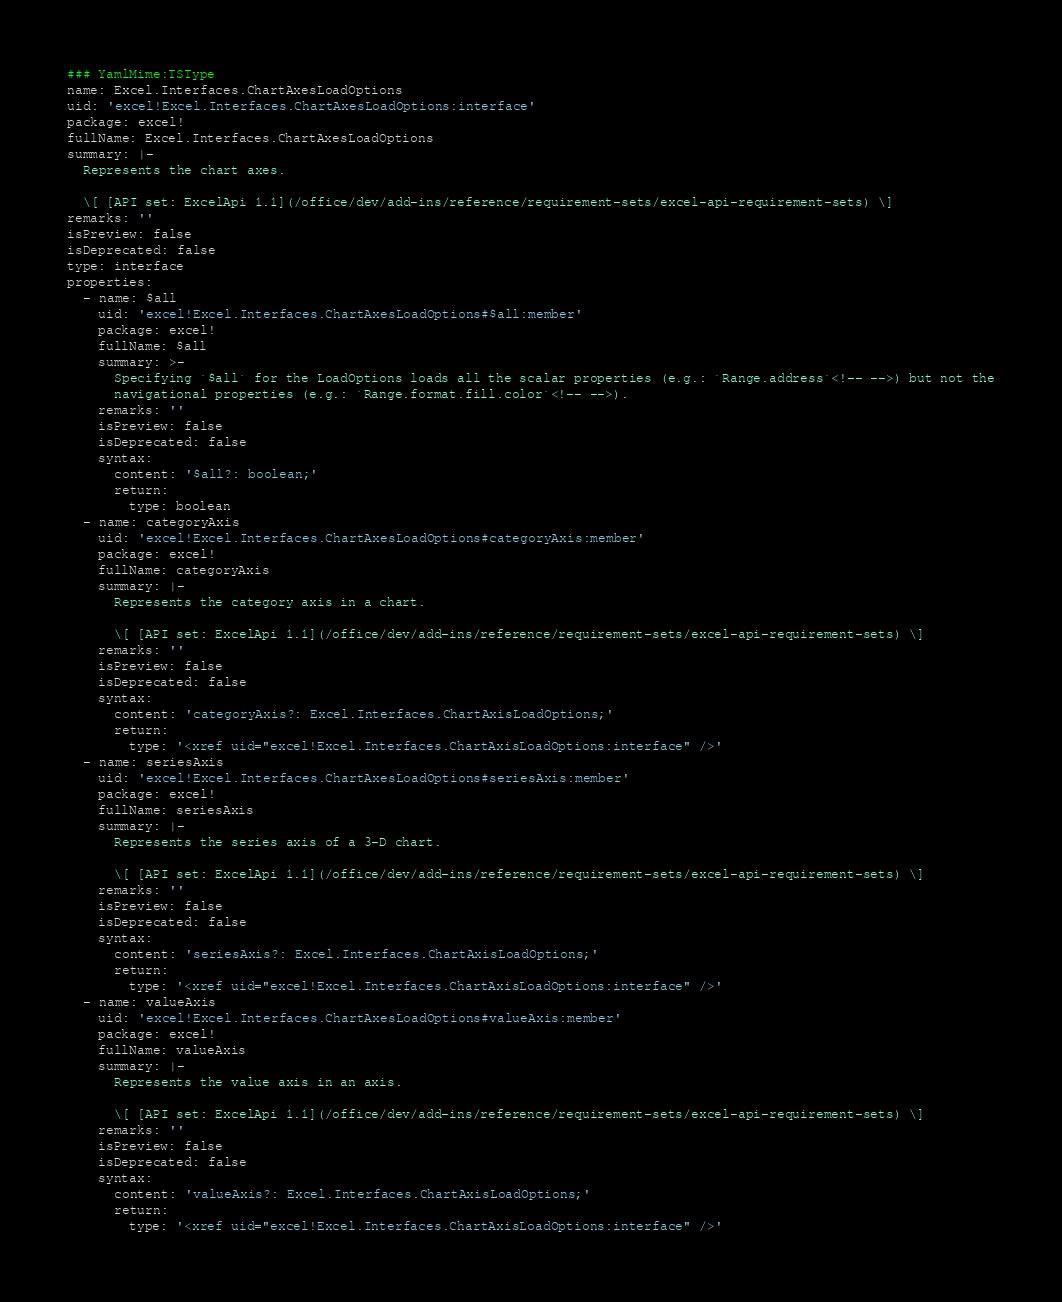<code> <loc_0><loc_0><loc_500><loc_500><_YAML_>### YamlMime:TSType
name: Excel.Interfaces.ChartAxesLoadOptions
uid: 'excel!Excel.Interfaces.ChartAxesLoadOptions:interface'
package: excel!
fullName: Excel.Interfaces.ChartAxesLoadOptions
summary: |-
  Represents the chart axes.

  \[ [API set: ExcelApi 1.1](/office/dev/add-ins/reference/requirement-sets/excel-api-requirement-sets) \]
remarks: ''
isPreview: false
isDeprecated: false
type: interface
properties:
  - name: $all
    uid: 'excel!Excel.Interfaces.ChartAxesLoadOptions#$all:member'
    package: excel!
    fullName: $all
    summary: >-
      Specifying `$all` for the LoadOptions loads all the scalar properties (e.g.: `Range.address`<!-- -->) but not the
      navigational properties (e.g.: `Range.format.fill.color`<!-- -->).
    remarks: ''
    isPreview: false
    isDeprecated: false
    syntax:
      content: '$all?: boolean;'
      return:
        type: boolean
  - name: categoryAxis
    uid: 'excel!Excel.Interfaces.ChartAxesLoadOptions#categoryAxis:member'
    package: excel!
    fullName: categoryAxis
    summary: |-
      Represents the category axis in a chart.

      \[ [API set: ExcelApi 1.1](/office/dev/add-ins/reference/requirement-sets/excel-api-requirement-sets) \]
    remarks: ''
    isPreview: false
    isDeprecated: false
    syntax:
      content: 'categoryAxis?: Excel.Interfaces.ChartAxisLoadOptions;'
      return:
        type: '<xref uid="excel!Excel.Interfaces.ChartAxisLoadOptions:interface" />'
  - name: seriesAxis
    uid: 'excel!Excel.Interfaces.ChartAxesLoadOptions#seriesAxis:member'
    package: excel!
    fullName: seriesAxis
    summary: |-
      Represents the series axis of a 3-D chart.

      \[ [API set: ExcelApi 1.1](/office/dev/add-ins/reference/requirement-sets/excel-api-requirement-sets) \]
    remarks: ''
    isPreview: false
    isDeprecated: false
    syntax:
      content: 'seriesAxis?: Excel.Interfaces.ChartAxisLoadOptions;'
      return:
        type: '<xref uid="excel!Excel.Interfaces.ChartAxisLoadOptions:interface" />'
  - name: valueAxis
    uid: 'excel!Excel.Interfaces.ChartAxesLoadOptions#valueAxis:member'
    package: excel!
    fullName: valueAxis
    summary: |-
      Represents the value axis in an axis.

      \[ [API set: ExcelApi 1.1](/office/dev/add-ins/reference/requirement-sets/excel-api-requirement-sets) \]
    remarks: ''
    isPreview: false
    isDeprecated: false
    syntax:
      content: 'valueAxis?: Excel.Interfaces.ChartAxisLoadOptions;'
      return:
        type: '<xref uid="excel!Excel.Interfaces.ChartAxisLoadOptions:interface" />'
</code> 